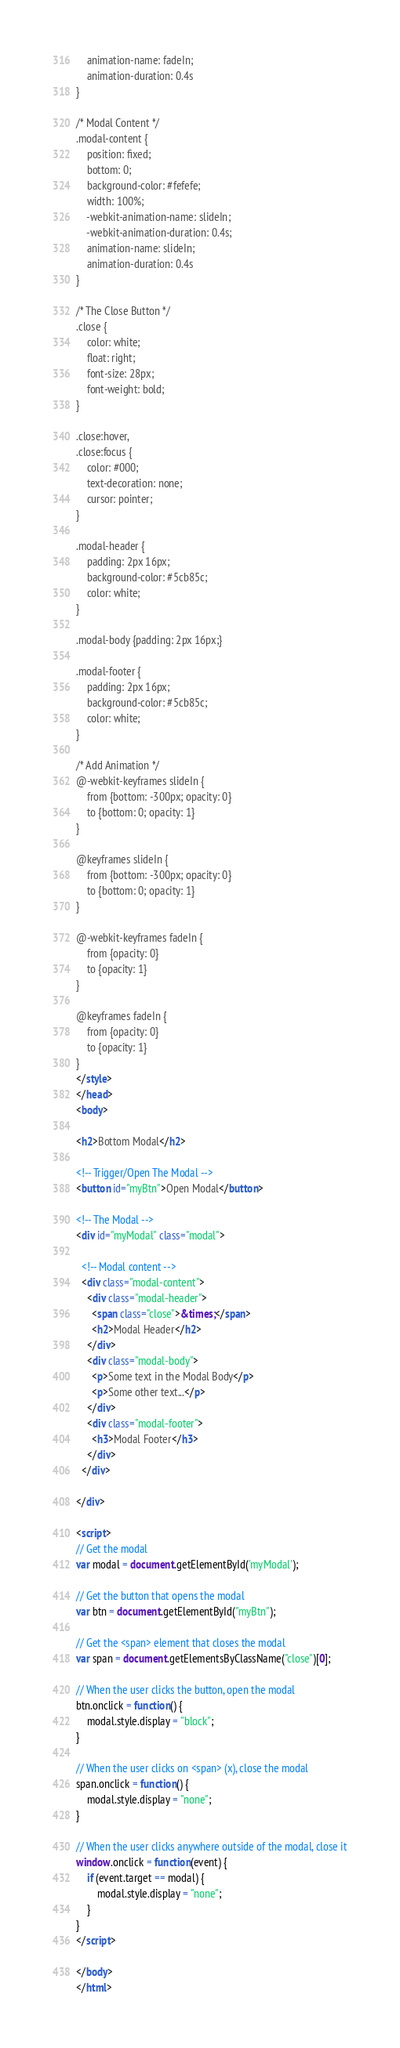Convert code to text. <code><loc_0><loc_0><loc_500><loc_500><_HTML_>    animation-name: fadeIn;
    animation-duration: 0.4s
}

/* Modal Content */
.modal-content {
    position: fixed;
    bottom: 0;
    background-color: #fefefe;
    width: 100%;
    -webkit-animation-name: slideIn;
    -webkit-animation-duration: 0.4s;
    animation-name: slideIn;
    animation-duration: 0.4s
}

/* The Close Button */
.close {
    color: white;
    float: right;
    font-size: 28px;
    font-weight: bold;
}

.close:hover,
.close:focus {
    color: #000;
    text-decoration: none;
    cursor: pointer;
}

.modal-header {
    padding: 2px 16px;
    background-color: #5cb85c;
    color: white;
}

.modal-body {padding: 2px 16px;}

.modal-footer {
    padding: 2px 16px;
    background-color: #5cb85c;
    color: white;
}

/* Add Animation */
@-webkit-keyframes slideIn {
    from {bottom: -300px; opacity: 0} 
    to {bottom: 0; opacity: 1}
}

@keyframes slideIn {
    from {bottom: -300px; opacity: 0}
    to {bottom: 0; opacity: 1}
}

@-webkit-keyframes fadeIn {
    from {opacity: 0} 
    to {opacity: 1}
}

@keyframes fadeIn {
    from {opacity: 0} 
    to {opacity: 1}
}
</style>
</head>
<body>

<h2>Bottom Modal</h2>

<!-- Trigger/Open The Modal -->
<button id="myBtn">Open Modal</button>

<!-- The Modal -->
<div id="myModal" class="modal">

  <!-- Modal content -->
  <div class="modal-content">
    <div class="modal-header">
      <span class="close">&times;</span>
      <h2>Modal Header</h2>
    </div>
    <div class="modal-body">
      <p>Some text in the Modal Body</p>
      <p>Some other text...</p>
    </div>
    <div class="modal-footer">
      <h3>Modal Footer</h3>
    </div>
  </div>

</div>

<script>
// Get the modal
var modal = document.getElementById('myModal');

// Get the button that opens the modal
var btn = document.getElementById("myBtn");

// Get the <span> element that closes the modal
var span = document.getElementsByClassName("close")[0];

// When the user clicks the button, open the modal 
btn.onclick = function() {
    modal.style.display = "block";
}

// When the user clicks on <span> (x), close the modal
span.onclick = function() {
    modal.style.display = "none";
}

// When the user clicks anywhere outside of the modal, close it
window.onclick = function(event) {
    if (event.target == modal) {
        modal.style.display = "none";
    }
}
</script>

</body>
</html>
</code> 